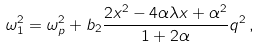Convert formula to latex. <formula><loc_0><loc_0><loc_500><loc_500>\omega _ { 1 } ^ { 2 } = \omega _ { p } ^ { 2 } + b _ { 2 } \frac { 2 x ^ { 2 } - 4 \alpha \lambda x + \alpha ^ { 2 } } { 1 + 2 \alpha } q ^ { 2 } \, ,</formula> 